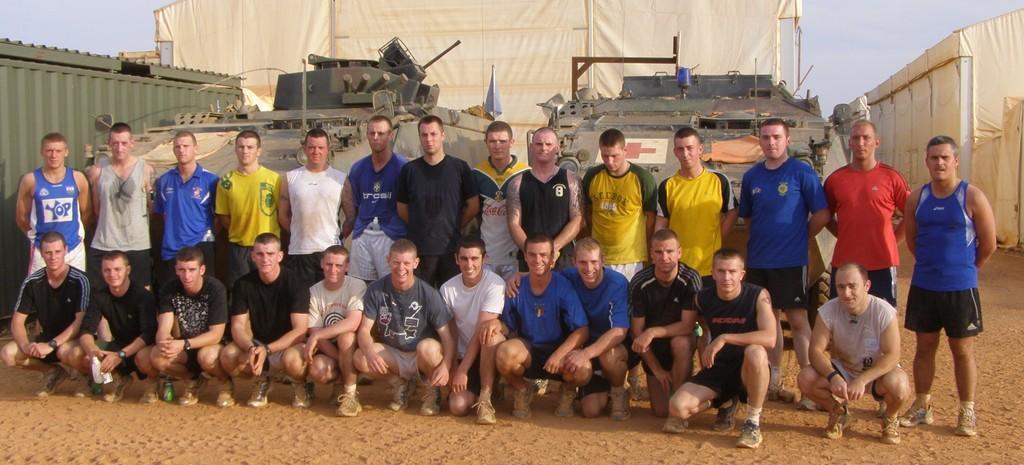Describe this image in one or two sentences. In this image I can see there is a group of people standing and few of them are sitting in the squatting position and there are military tanks in the background and there are tents and the sky is clear. 